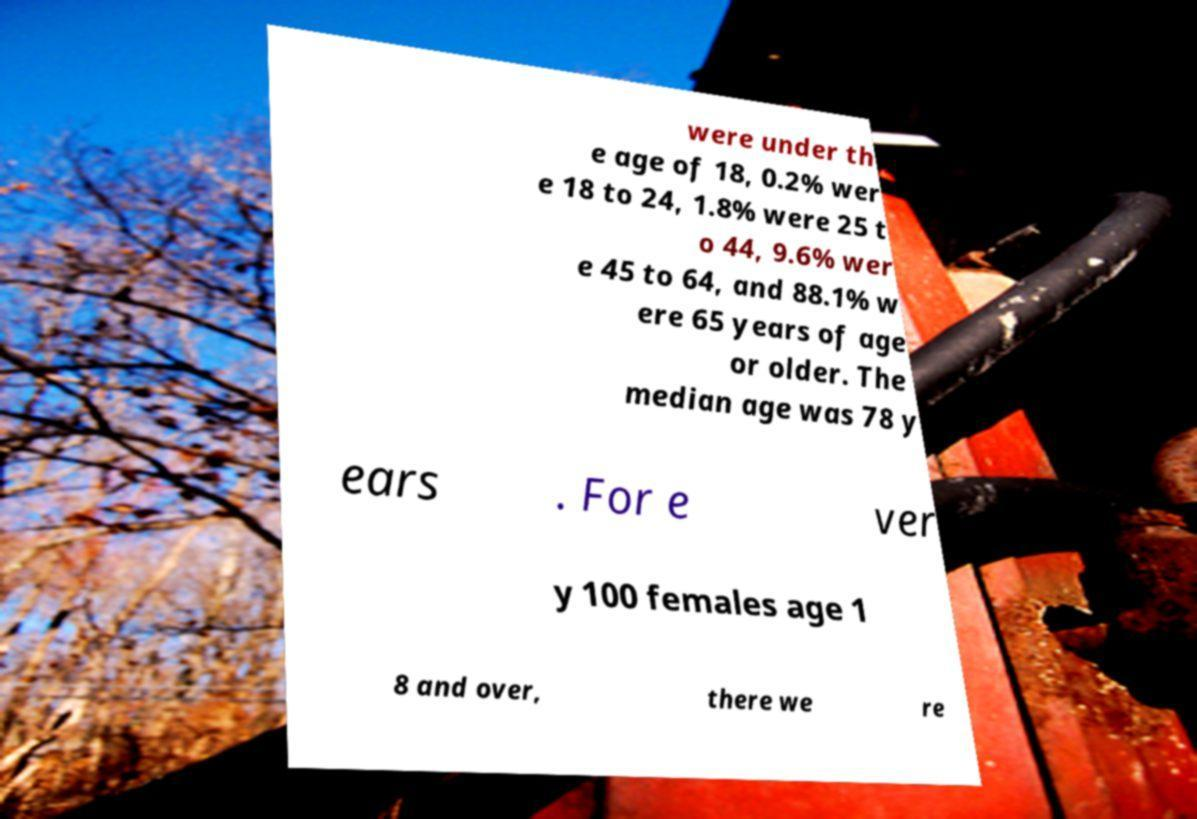What messages or text are displayed in this image? I need them in a readable, typed format. were under th e age of 18, 0.2% wer e 18 to 24, 1.8% were 25 t o 44, 9.6% wer e 45 to 64, and 88.1% w ere 65 years of age or older. The median age was 78 y ears . For e ver y 100 females age 1 8 and over, there we re 